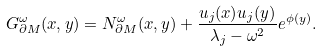Convert formula to latex. <formula><loc_0><loc_0><loc_500><loc_500>G ^ { \omega } _ { \partial M } ( x , y ) = N ^ { \omega } _ { \partial M } ( x , y ) + \frac { u _ { j } ( x ) u _ { j } ( y ) } { \lambda _ { j } - \omega ^ { 2 } } e ^ { \phi ( y ) } .</formula> 